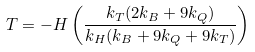Convert formula to latex. <formula><loc_0><loc_0><loc_500><loc_500>T = - H \left ( \frac { k _ { T } ( 2 k _ { B } + 9 k _ { Q } ) } { k _ { H } ( k _ { B } + 9 k _ { Q } + 9 k _ { T } ) } \right )</formula> 